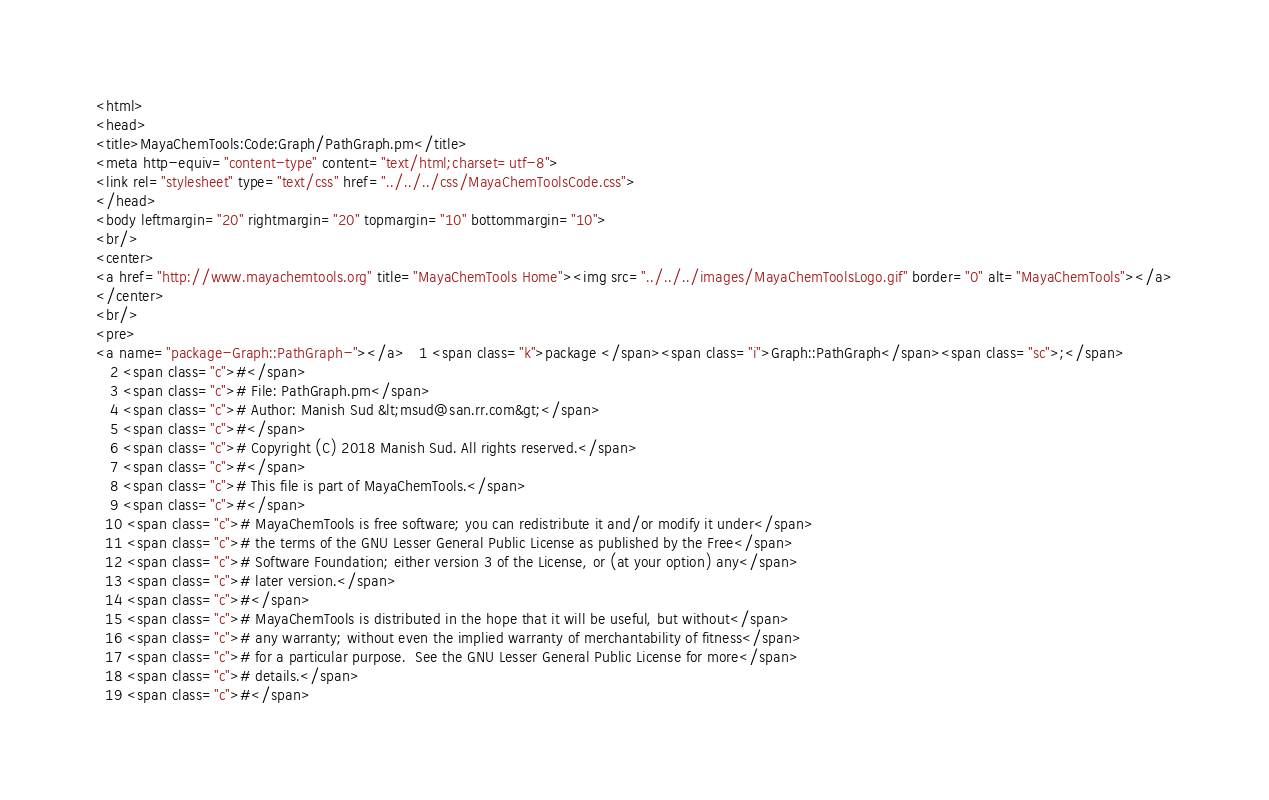Convert code to text. <code><loc_0><loc_0><loc_500><loc_500><_HTML_><html>
<head>
<title>MayaChemTools:Code:Graph/PathGraph.pm</title>
<meta http-equiv="content-type" content="text/html;charset=utf-8">
<link rel="stylesheet" type="text/css" href="../../../css/MayaChemToolsCode.css">
</head>
<body leftmargin="20" rightmargin="20" topmargin="10" bottommargin="10">
<br/>
<center>
<a href="http://www.mayachemtools.org" title="MayaChemTools Home"><img src="../../../images/MayaChemToolsLogo.gif" border="0" alt="MayaChemTools"></a>
</center>
<br/>
<pre>
<a name="package-Graph::PathGraph-"></a>   1 <span class="k">package </span><span class="i">Graph::PathGraph</span><span class="sc">;</span>
   2 <span class="c">#</span>
   3 <span class="c"># File: PathGraph.pm</span>
   4 <span class="c"># Author: Manish Sud &lt;msud@san.rr.com&gt;</span>
   5 <span class="c">#</span>
   6 <span class="c"># Copyright (C) 2018 Manish Sud. All rights reserved.</span>
   7 <span class="c">#</span>
   8 <span class="c"># This file is part of MayaChemTools.</span>
   9 <span class="c">#</span>
  10 <span class="c"># MayaChemTools is free software; you can redistribute it and/or modify it under</span>
  11 <span class="c"># the terms of the GNU Lesser General Public License as published by the Free</span>
  12 <span class="c"># Software Foundation; either version 3 of the License, or (at your option) any</span>
  13 <span class="c"># later version.</span>
  14 <span class="c">#</span>
  15 <span class="c"># MayaChemTools is distributed in the hope that it will be useful, but without</span>
  16 <span class="c"># any warranty; without even the implied warranty of merchantability of fitness</span>
  17 <span class="c"># for a particular purpose.  See the GNU Lesser General Public License for more</span>
  18 <span class="c"># details.</span>
  19 <span class="c">#</span></code> 